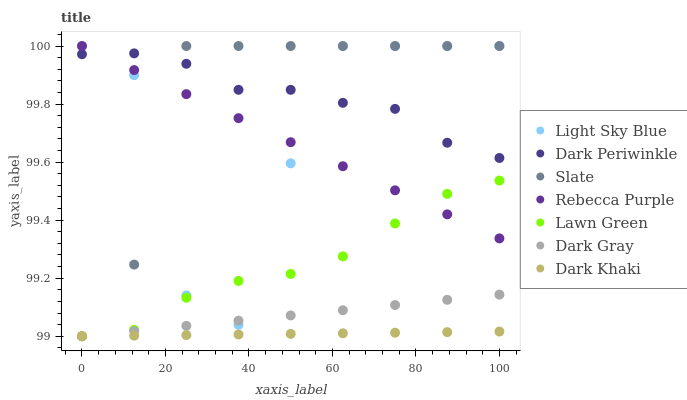Does Dark Khaki have the minimum area under the curve?
Answer yes or no. Yes. Does Slate have the maximum area under the curve?
Answer yes or no. Yes. Does Dark Gray have the minimum area under the curve?
Answer yes or no. No. Does Dark Gray have the maximum area under the curve?
Answer yes or no. No. Is Dark Khaki the smoothest?
Answer yes or no. Yes. Is Light Sky Blue the roughest?
Answer yes or no. Yes. Is Slate the smoothest?
Answer yes or no. No. Is Slate the roughest?
Answer yes or no. No. Does Lawn Green have the lowest value?
Answer yes or no. Yes. Does Slate have the lowest value?
Answer yes or no. No. Does Rebecca Purple have the highest value?
Answer yes or no. Yes. Does Dark Gray have the highest value?
Answer yes or no. No. Is Dark Khaki less than Slate?
Answer yes or no. Yes. Is Light Sky Blue greater than Dark Khaki?
Answer yes or no. Yes. Does Light Sky Blue intersect Rebecca Purple?
Answer yes or no. Yes. Is Light Sky Blue less than Rebecca Purple?
Answer yes or no. No. Is Light Sky Blue greater than Rebecca Purple?
Answer yes or no. No. Does Dark Khaki intersect Slate?
Answer yes or no. No. 